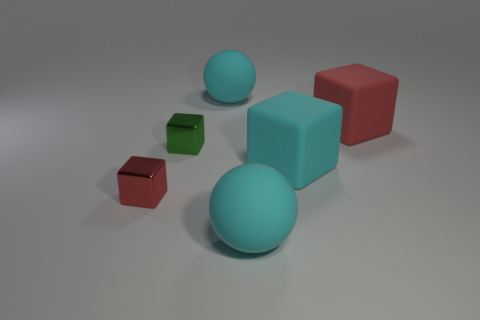Are there more cyan balls that are behind the large red matte thing than small green objects on the right side of the big cyan rubber cube?
Provide a short and direct response. Yes. There is a cyan block that is made of the same material as the big red block; what size is it?
Your response must be concise. Large. There is a red thing in front of the red block right of the large sphere that is in front of the large red rubber cube; how big is it?
Offer a very short reply. Small. What is the color of the metal thing that is behind the tiny red metal thing?
Your response must be concise. Green. Are there more red cubes in front of the small green block than tiny red metallic spheres?
Your answer should be compact. Yes. There is a red object to the left of the large red thing; is it the same shape as the large red rubber object?
Give a very brief answer. Yes. How many green things are large rubber blocks or large balls?
Provide a short and direct response. 0. Is the number of metallic blocks greater than the number of objects?
Offer a terse response. No. There is another object that is the same size as the red shiny thing; what is its color?
Your response must be concise. Green. What number of blocks are either metal things or small purple matte objects?
Offer a very short reply. 2. 